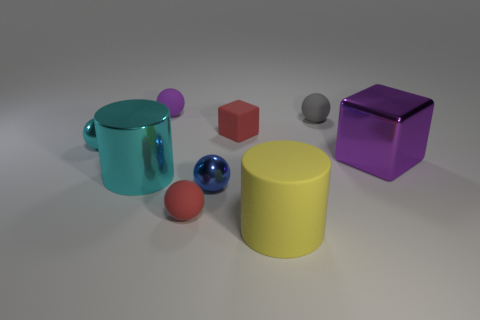The shiny object that is the same size as the blue ball is what shape?
Make the answer very short. Sphere. Is there a blue shiny ball that has the same size as the purple cube?
Give a very brief answer. No. What material is the cyan sphere that is the same size as the blue ball?
Your answer should be very brief. Metal. There is a object on the right side of the tiny rubber object that is right of the red rubber block; what size is it?
Your answer should be compact. Large. Do the cylinder that is to the right of the purple ball and the purple rubber thing have the same size?
Ensure brevity in your answer.  No. Are there more blocks that are to the right of the big metal cylinder than small purple objects in front of the red matte cube?
Offer a very short reply. Yes. The tiny matte object that is to the right of the small blue shiny thing and to the left of the gray rubber thing has what shape?
Keep it short and to the point. Cube. There is a cyan object that is behind the large metal cylinder; what shape is it?
Provide a short and direct response. Sphere. How big is the purple thing in front of the red matte object that is behind the metal ball that is on the left side of the blue sphere?
Make the answer very short. Large. Is the tiny cyan object the same shape as the large purple metal thing?
Your response must be concise. No. 